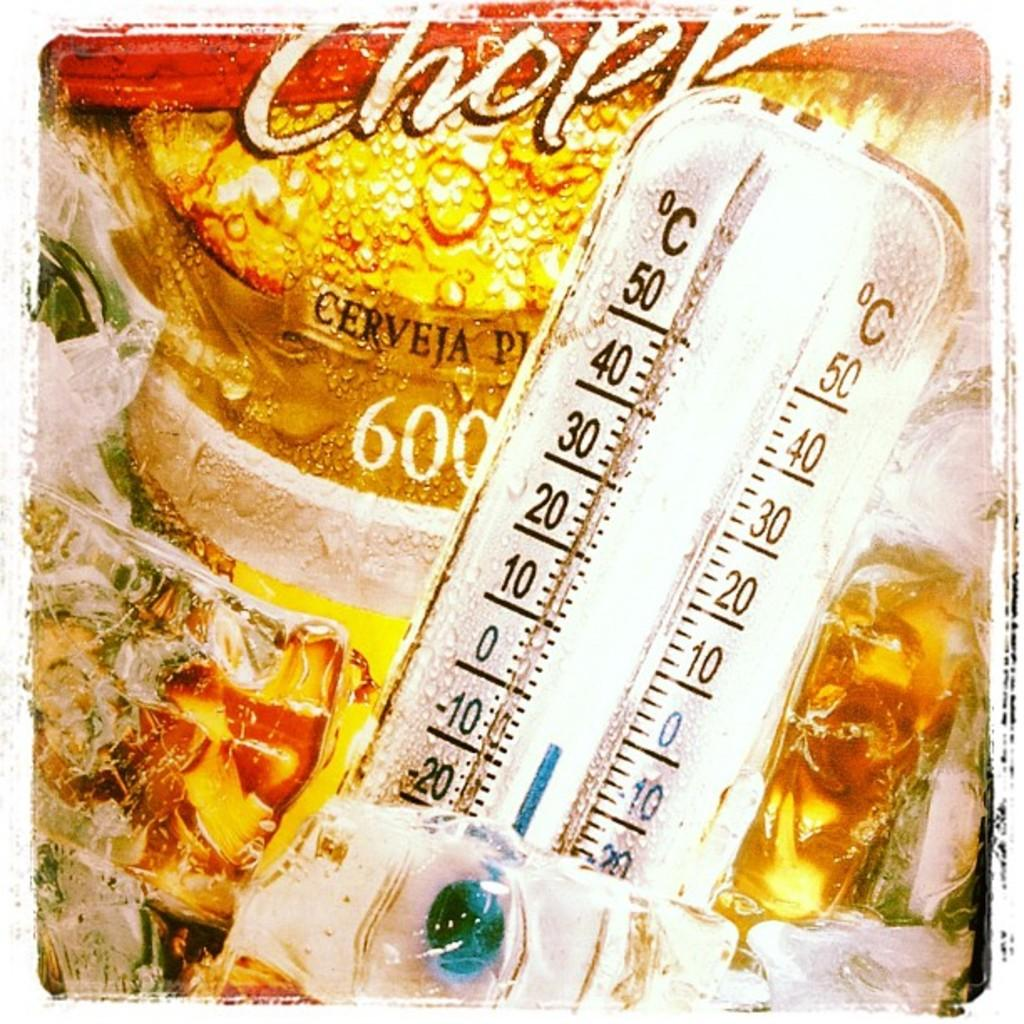What device is visible in the front of the image? There is a temperature meter in the front of the image. What is located behind the temperature meter? There is a paper cover behind the temperature meter. What can be found on the paper cover? The paper cover has text written on it. What type of silk material is used to make the temperature meter in the image? There is no silk material used to make the temperature meter in the image; it is an electronic device. 